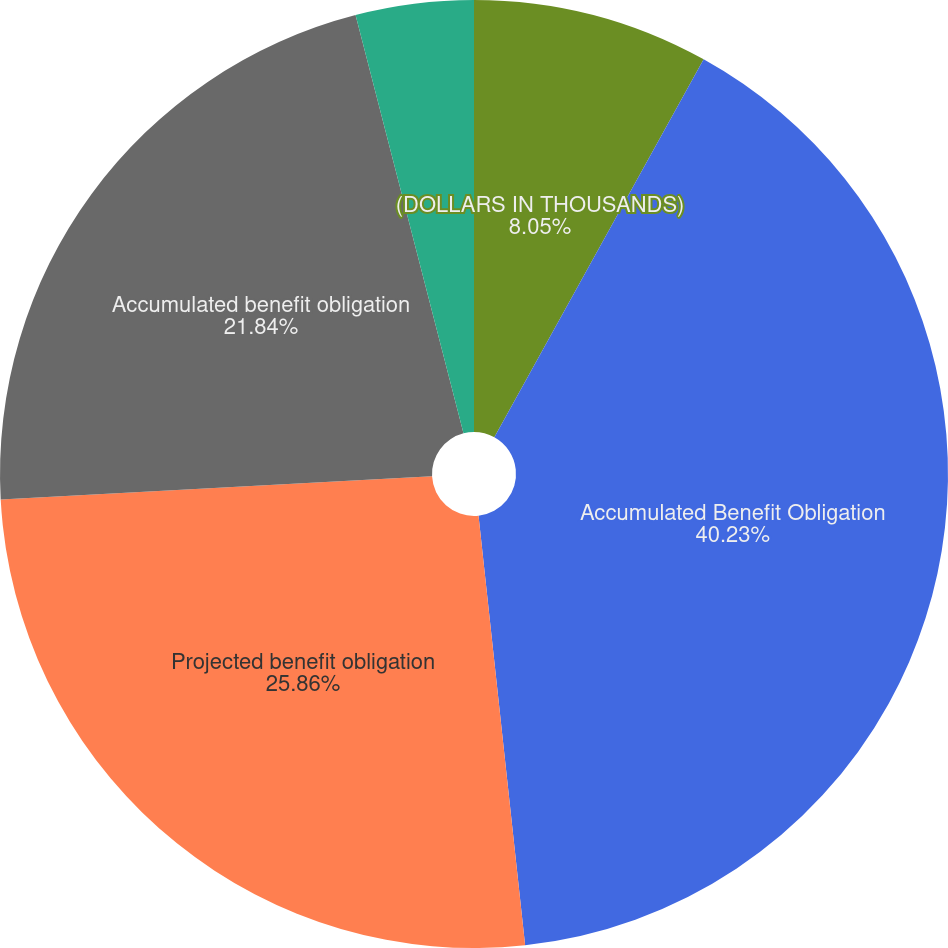Convert chart. <chart><loc_0><loc_0><loc_500><loc_500><pie_chart><fcel>(DOLLARS IN THOUSANDS)<fcel>Accumulated Benefit Obligation<fcel>Projected benefit obligation<fcel>Accumulated benefit obligation<fcel>Discount rate<fcel>Rate of compensation increase<nl><fcel>8.05%<fcel>40.23%<fcel>25.86%<fcel>21.84%<fcel>4.02%<fcel>0.0%<nl></chart> 